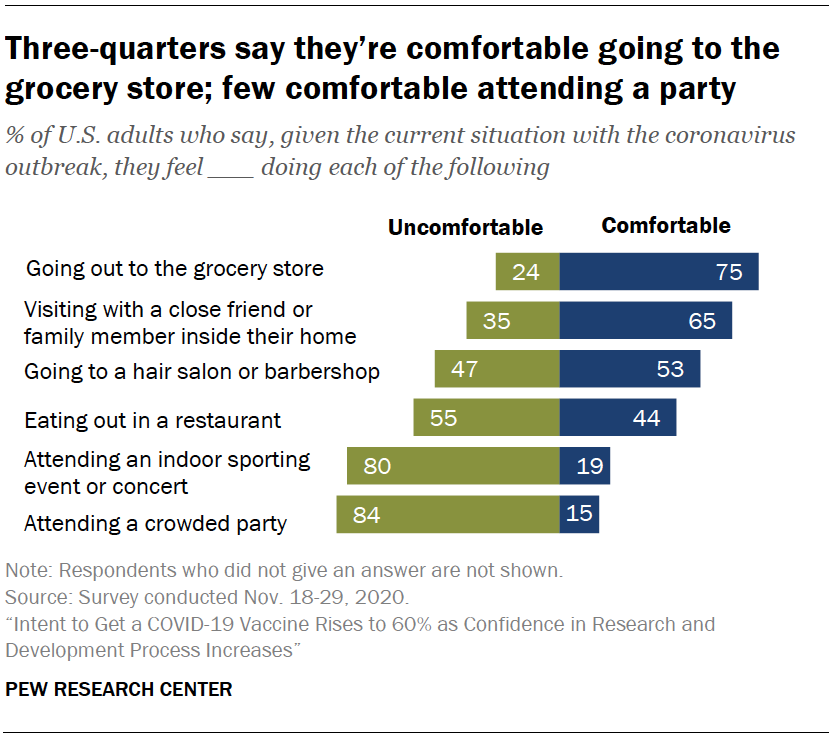List a handful of essential elements in this visual. The ratio of uncomfortable to comfortable experiences when eating out in a restaurant is 0.211111111... The color of bars whose values are decreasing from top to bottom is blue. 